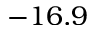<formula> <loc_0><loc_0><loc_500><loc_500>- 1 6 . 9</formula> 